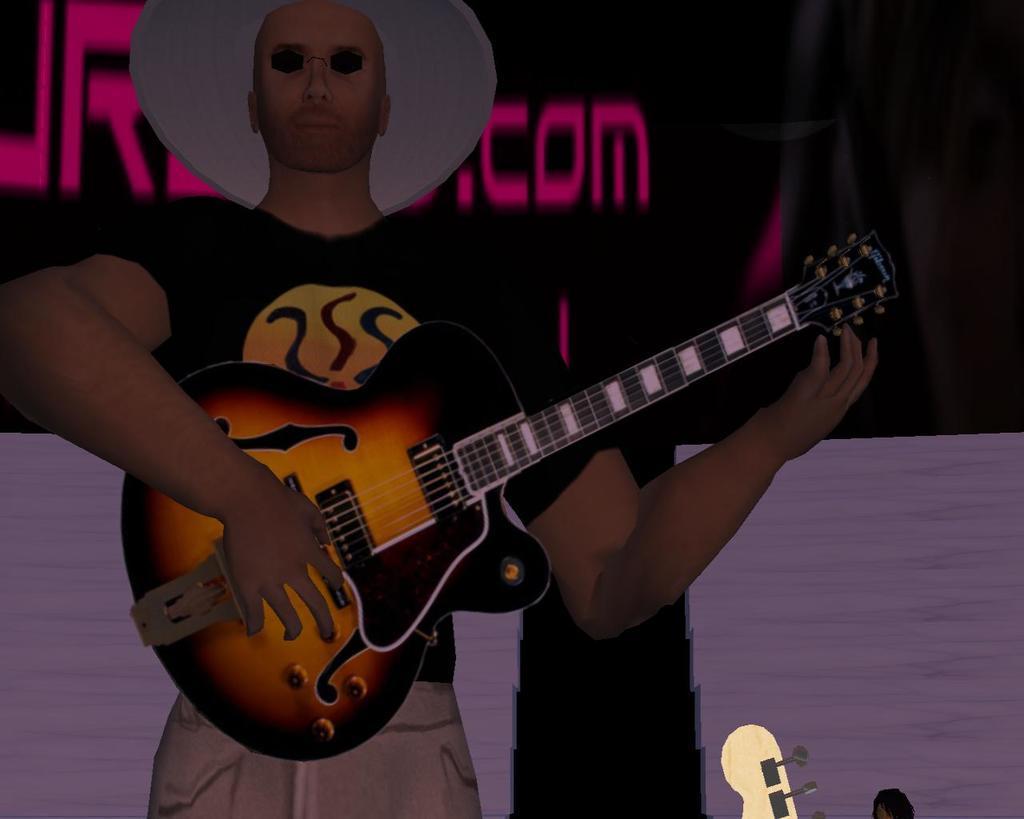In one or two sentences, can you explain what this image depicts? This is an animated image. In this image we can see a person standing holding a guitar. On the backside we can see some text on a wall. On the right bottom we can see some strings of a guitar. 